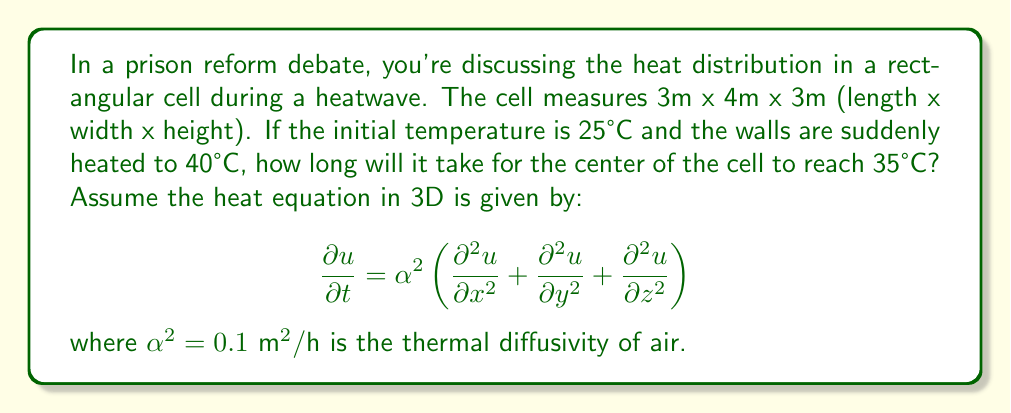Solve this math problem. To solve this problem, we need to use the solution to the 3D heat equation for a rectangular prism with fixed boundary conditions. The solution is given by:

$$u(x,y,z,t) = u_f + \sum_{l=1}^{\infty}\sum_{m=1}^{\infty}\sum_{n=1}^{\infty} A_{lmn} \sin\left(\frac{l\pi x}{L}\right)\sin\left(\frac{m\pi y}{W}\right)\sin\left(\frac{n\pi z}{H}\right)e^{-\alpha^2\beta_{lmn}^2t}$$

where $u_f$ is the final temperature (40°C), $L$, $W$, and $H$ are the dimensions of the cell, and:

$$\beta_{lmn}^2 = \left(\frac{l\pi}{L}\right)^2 + \left(\frac{m\pi}{W}\right)^2 + \left(\frac{n\pi}{H}\right)^2$$

$$A_{lmn} = \frac{8(u_i - u_f)}{lmn\pi^3}\sin\left(\frac{l\pi}{2}\right)\sin\left(\frac{m\pi}{2}\right)\sin\left(\frac{n\pi}{2}\right)$$

where $u_i$ is the initial temperature (25°C).

At the center of the cell $(x=L/2, y=W/2, z=H/2)$, we only need to consider odd values of $l$, $m$, and $n$. The first term $(l=m=n=1)$ will be dominant, so we can approximate:

$$u(L/2,W/2,H/2,t) \approx 40 - \frac{8(40-25)}{\pi^3}e^{-\alpha^2\beta_{111}^2t}$$

where $\beta_{111}^2 = \pi^2\left(\frac{1}{3^2} + \frac{1}{4^2} + \frac{1}{3^2}\right) = \frac{13\pi^2}{36}$.

We want to find $t$ when $u(L/2,W/2,H/2,t) = 35°C$:

$$35 = 40 - \frac{120}{\pi^3}e^{-0.1\cdot\frac{13\pi^2}{36}t}$$

Solving for $t$:

$$t = -\frac{36}{1.3\pi^2}\ln\left(\frac{5\pi^3}{120}\right) \approx 2.76 \text{ hours}$$
Answer: 2.76 hours 